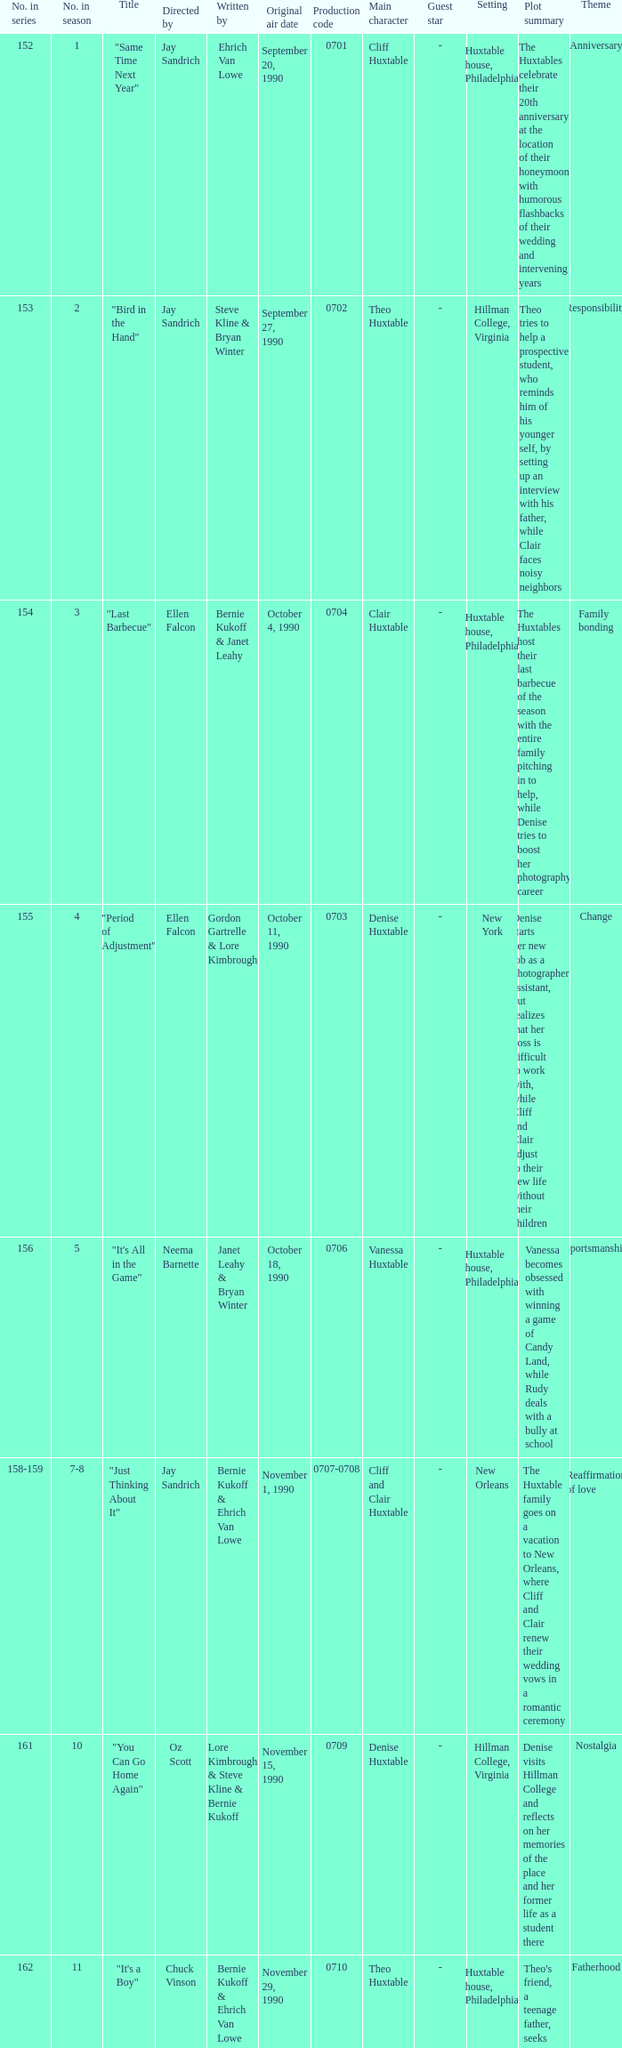Where was the episode "adventures in babysitting" placed in terms of the season's episode order? 17.0. 